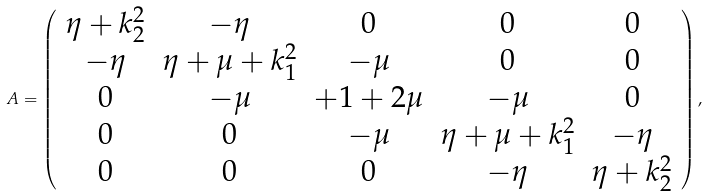Convert formula to latex. <formula><loc_0><loc_0><loc_500><loc_500>A = \left ( \begin{array} { c c c c c } \eta + k _ { 2 } ^ { 2 } & - \eta & 0 & 0 & 0 \\ - \eta & \eta + \mu + k _ { 1 } ^ { 2 } & - \mu & 0 & 0 \\ 0 & - \mu & + 1 + 2 \mu & - \mu & 0 \\ 0 & 0 & - \mu & \eta + \mu + k _ { 1 } ^ { 2 } & - \eta \\ 0 & 0 & 0 & - \eta & \eta + k _ { 2 } ^ { 2 } \\ \end{array} \right ) ,</formula> 